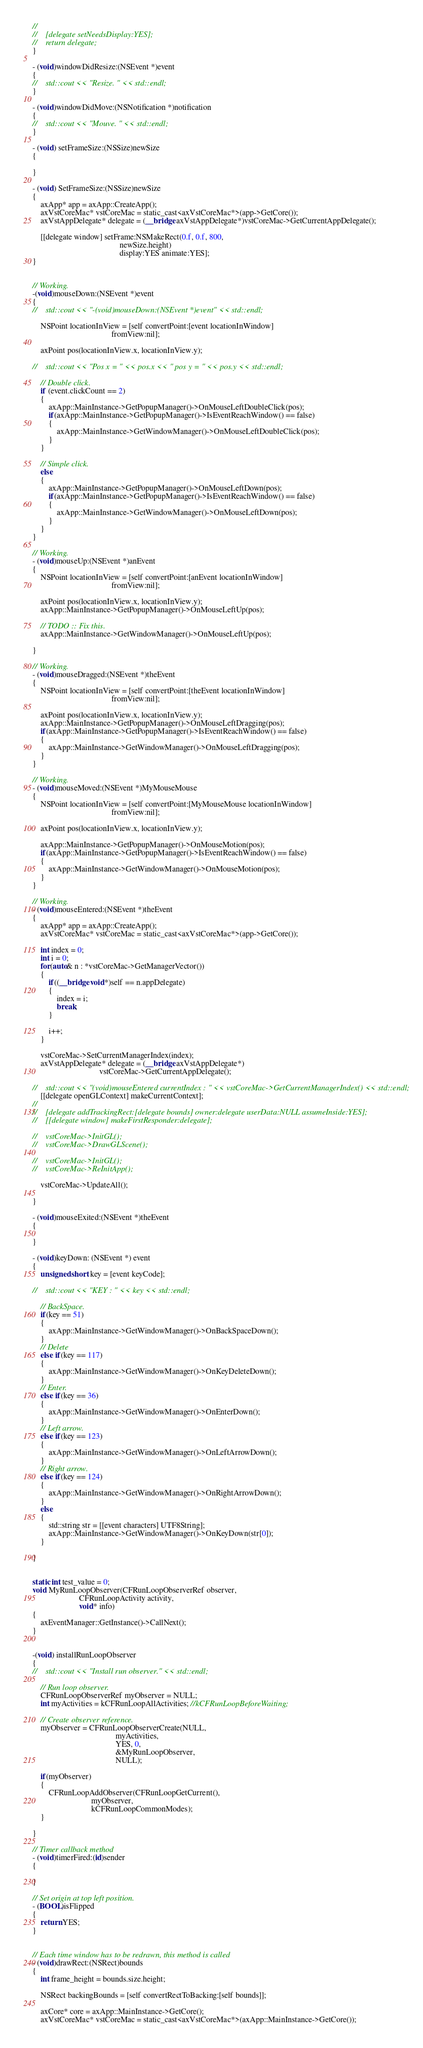<code> <loc_0><loc_0><loc_500><loc_500><_ObjectiveC_>//
//    [delegate setNeedsDisplay:YES];
//    return delegate;
}

- (void)windowDidResize:(NSEvent *)event
{
//    std::cout << "Resize. " << std::endl;
}

- (void)windowDidMove:(NSNotification *)notification
{
//    std::cout << "Mouve. " << std::endl;
}

- (void) setFrameSize:(NSSize)newSize
{

}

- (void) SetFrameSize:(NSSize)newSize
{
    axApp* app = axApp::CreateApp();
    axVstCoreMac* vstCoreMac = static_cast<axVstCoreMac*>(app->GetCore());
    axVstAppDelegate* delegate = (__bridge axVstAppDelegate*)vstCoreMac->GetCurrentAppDelegate();
    
    [[delegate window] setFrame:NSMakeRect(0.f, 0.f, 800,
                                           newSize.height)
                                           display:YES animate:YES];
}


// Working.
-(void)mouseDown:(NSEvent *)event
{
//    std::cout << "-(void)mouseDown:(NSEvent *)event" << std::endl;

    NSPoint locationInView = [self convertPoint:[event locationInWindow]
                                       fromView:nil];
    
    axPoint pos(locationInView.x, locationInView.y);
    
//    std::cout << "Pos x = " << pos.x << " pos y = " << pos.y << std::endl;
    
    // Double click.
    if (event.clickCount == 2)
    {
        axApp::MainInstance->GetPopupManager()->OnMouseLeftDoubleClick(pos);
        if(axApp::MainInstance->GetPopupManager()->IsEventReachWindow() == false)
        {
            axApp::MainInstance->GetWindowManager()->OnMouseLeftDoubleClick(pos);
        }
    }
    
    // Simple click.
    else
    {
        axApp::MainInstance->GetPopupManager()->OnMouseLeftDown(pos);
        if(axApp::MainInstance->GetPopupManager()->IsEventReachWindow() == false)
        {
            axApp::MainInstance->GetWindowManager()->OnMouseLeftDown(pos);
        }
    }
}

// Working.
- (void)mouseUp:(NSEvent *)anEvent
{
    NSPoint locationInView = [self convertPoint:[anEvent locationInWindow]
                                       fromView:nil];

    axPoint pos(locationInView.x, locationInView.y);
    axApp::MainInstance->GetPopupManager()->OnMouseLeftUp(pos);

    // TODO :: Fix this.
    axApp::MainInstance->GetWindowManager()->OnMouseLeftUp(pos);

}

// Working.
- (void)mouseDragged:(NSEvent *)theEvent
{
    NSPoint locationInView = [self convertPoint:[theEvent locationInWindow]
                                       fromView:nil];
    
    axPoint pos(locationInView.x, locationInView.y);
    axApp::MainInstance->GetPopupManager()->OnMouseLeftDragging(pos);
    if(axApp::MainInstance->GetPopupManager()->IsEventReachWindow() == false)
    {
        axApp::MainInstance->GetWindowManager()->OnMouseLeftDragging(pos);
    }
}

// Working.
- (void)mouseMoved:(NSEvent *)MyMouseMouse
{
    NSPoint locationInView = [self convertPoint:[MyMouseMouse locationInWindow]
                                       fromView:nil];

    axPoint pos(locationInView.x, locationInView.y);
    
    axApp::MainInstance->GetPopupManager()->OnMouseMotion(pos);
    if(axApp::MainInstance->GetPopupManager()->IsEventReachWindow() == false)
    {
        axApp::MainInstance->GetWindowManager()->OnMouseMotion(pos);
    }
}

// Working.
- (void)mouseEntered:(NSEvent *)theEvent
{
    axApp* app = axApp::CreateApp();
    axVstCoreMac* vstCoreMac = static_cast<axVstCoreMac*>(app->GetCore());
    
    int index = 0;
    int i = 0;
    for(auto& n : *vstCoreMac->GetManagerVector())
    {
        if((__bridge void*)self == n.appDelegate)
        {
            index = i;
            break;
        }
        
        i++;
    }
    
    vstCoreMac->SetCurrentManagerIndex(index);
    axVstAppDelegate* delegate = (__bridge axVstAppDelegate*)
                                 vstCoreMac->GetCurrentAppDelegate();
    
//    std::cout << "(void)mouseEntered currentIndex : " << vstCoreMac->GetCurrentManagerIndex() << std::endl;
    [[delegate openGLContext] makeCurrentContext];
//
//    [delegate addTrackingRect:[delegate bounds] owner:delegate userData:NULL assumeInside:YES];
//    [[delegate window] makeFirstResponder:delegate];

//    vstCoreMac->InitGL();
//    vstCoreMac->DrawGLScene();
    
//    vstCoreMac->InitGL();
//    vstCoreMac->ReInitApp();
    
    vstCoreMac->UpdateAll();
    
}

- (void)mouseExited:(NSEvent *)theEvent
{

}

- (void)keyDown: (NSEvent *) event
{
    unsigned short key = [event keyCode];
    
//    std::cout << "KEY : " << key << std::endl;
    
    // BackSpace.
    if(key == 51)
    {
        axApp::MainInstance->GetWindowManager()->OnBackSpaceDown();
    }
    // Delete
    else if(key == 117)
    {
        axApp::MainInstance->GetWindowManager()->OnKeyDeleteDown();
    }
    // Enter.
    else if(key == 36)
    {
        axApp::MainInstance->GetWindowManager()->OnEnterDown();
    }
    // Left arrow.
    else if(key == 123)
    {
        axApp::MainInstance->GetWindowManager()->OnLeftArrowDown();
    }
    // Right arrow.
    else if(key == 124)
    {
        axApp::MainInstance->GetWindowManager()->OnRightArrowDown();
    }
    else
    {
        std::string str = [[event characters] UTF8String];
        axApp::MainInstance->GetWindowManager()->OnKeyDown(str[0]);
    }
    
}


static int test_value = 0;
void MyRunLoopObserver(CFRunLoopObserverRef observer,
                       CFRunLoopActivity activity,
                       void* info)
{
    axEventManager::GetInstance()->CallNext();
}


-(void) installRunLoopObserver
{
//    std::cout << "Install run observer." << std::endl;
    
    // Run loop observer.
    CFRunLoopObserverRef myObserver = NULL;
    int myActivities = kCFRunLoopAllActivities; //kCFRunLoopBeforeWaiting;
    
    // Create observer reference.
    myObserver = CFRunLoopObserverCreate(NULL,
                                         myActivities,
                                         YES, 0,
                                         &MyRunLoopObserver,
                                         NULL);

    if(myObserver)
    {
        CFRunLoopAddObserver(CFRunLoopGetCurrent(),
                             myObserver,
                             kCFRunLoopCommonModes);
    }
    
}

// Timer callback method
- (void)timerFired:(id)sender
{

}

// Set origin at top left position.
- (BOOL)isFlipped
{
    return YES;
}


// Each time window has to be redrawn, this method is called
- (void)drawRect:(NSRect)bounds
{
    int frame_height = bounds.size.height;

    NSRect backingBounds = [self convertRectToBacking:[self bounds]];
    
    axCore* core = axApp::MainInstance->GetCore();
    axVstCoreMac* vstCoreMac = static_cast<axVstCoreMac*>(axApp::MainInstance->GetCore());</code> 